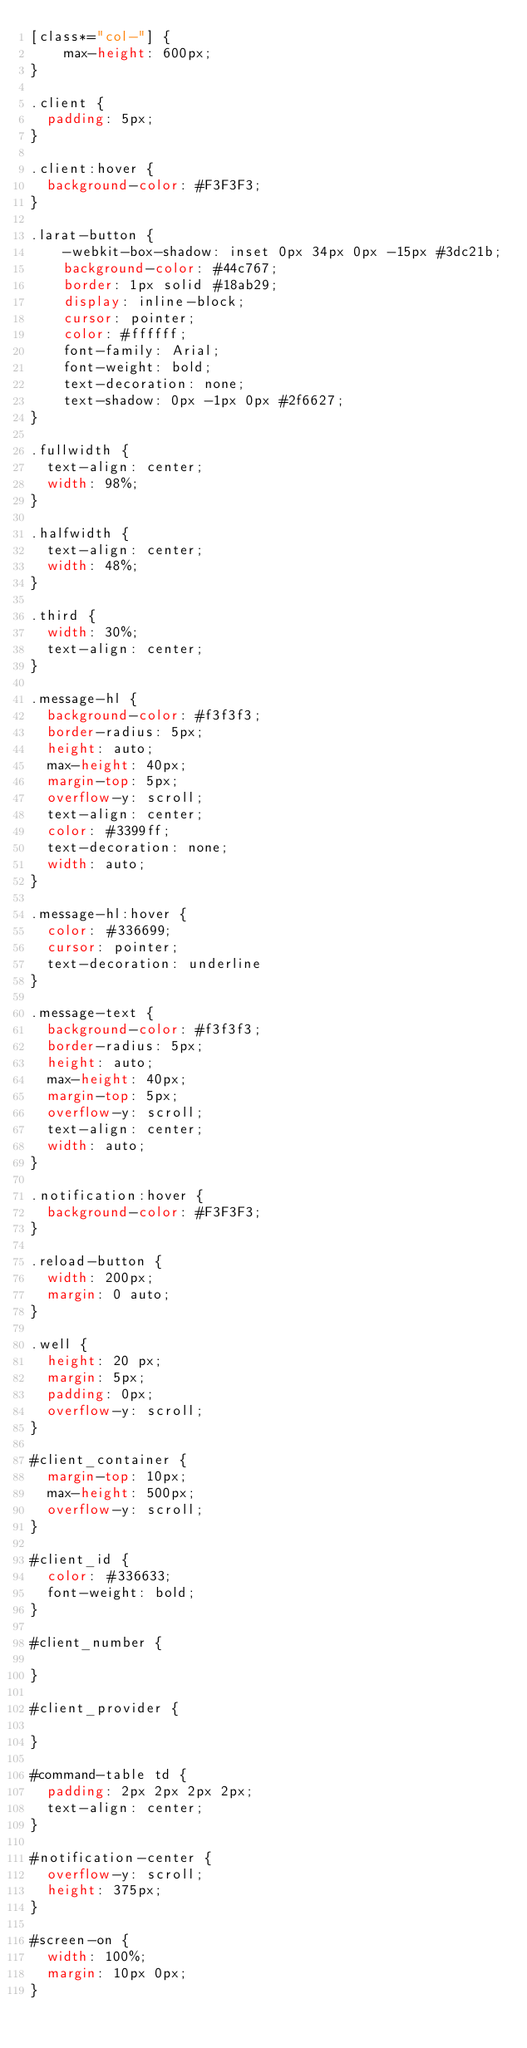Convert code to text. <code><loc_0><loc_0><loc_500><loc_500><_CSS_>[class*="col-"] {
    max-height: 600px;
}

.client {
  padding: 5px;
}

.client:hover {
  background-color: #F3F3F3;
}

.larat-button {
    -webkit-box-shadow: inset 0px 34px 0px -15px #3dc21b;
    background-color: #44c767;
    border: 1px solid #18ab29;
    display: inline-block;
    cursor: pointer;
    color: #ffffff;
    font-family: Arial;
    font-weight: bold;
    text-decoration: none;
    text-shadow: 0px -1px 0px #2f6627;
}

.fullwidth {
  text-align: center;
  width: 98%;
}

.halfwidth {
  text-align: center;
  width: 48%;
}

.third {
  width: 30%;
  text-align: center;
}

.message-hl {
  background-color: #f3f3f3;
  border-radius: 5px;
  height: auto;
  max-height: 40px;
  margin-top: 5px;
  overflow-y: scroll;
  text-align: center;
  color: #3399ff;
  text-decoration: none;
  width: auto;
}

.message-hl:hover {
  color: #336699;
  cursor: pointer;
  text-decoration: underline
}

.message-text {
  background-color: #f3f3f3;
  border-radius: 5px;
  height: auto;
  max-height: 40px;
  margin-top: 5px;
  overflow-y: scroll;
  text-align: center;
  width: auto;
}

.notification:hover {
  background-color: #F3F3F3;
}

.reload-button {
  width: 200px;
  margin: 0 auto;
}

.well {
  height: 20 px;
  margin: 5px;
  padding: 0px;
  overflow-y: scroll;
}

#client_container {
  margin-top: 10px;
  max-height: 500px;
  overflow-y: scroll;
}

#client_id {
  color: #336633;
  font-weight: bold;
}

#client_number {

}

#client_provider {

}

#command-table td {
  padding: 2px 2px 2px 2px;
  text-align: center;
}

#notification-center {
  overflow-y: scroll;
  height: 375px;
}

#screen-on {
  width: 100%;
  margin: 10px 0px;
}
</code> 